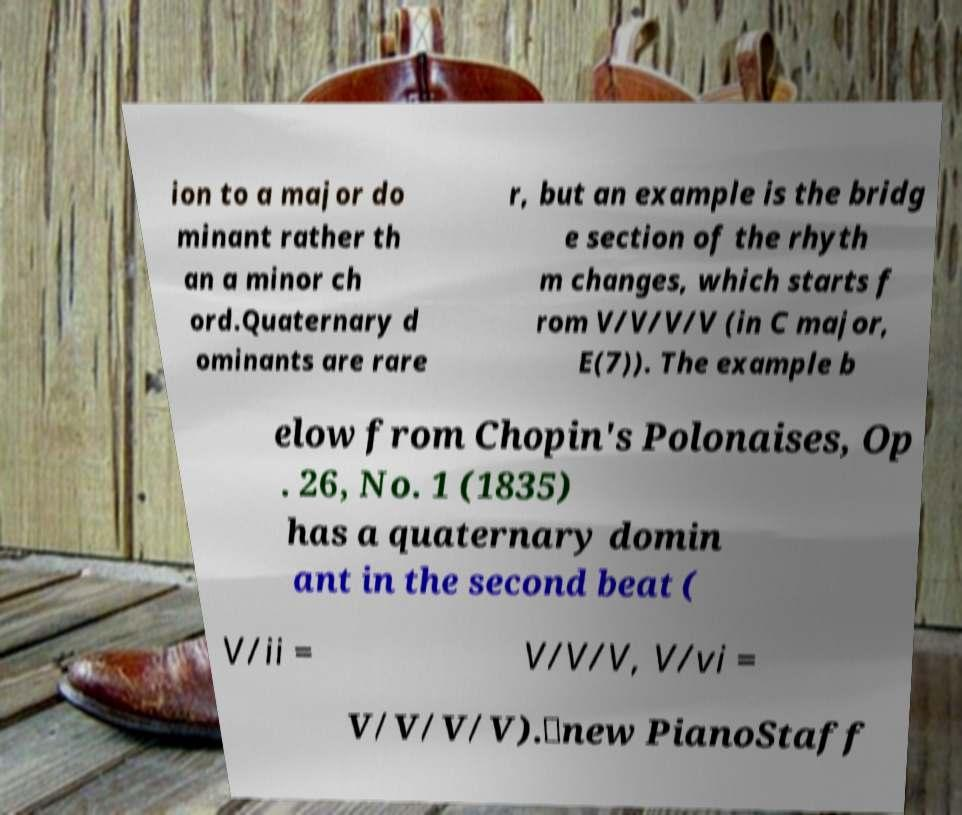Could you extract and type out the text from this image? ion to a major do minant rather th an a minor ch ord.Quaternary d ominants are rare r, but an example is the bridg e section of the rhyth m changes, which starts f rom V/V/V/V (in C major, E(7)). The example b elow from Chopin's Polonaises, Op . 26, No. 1 (1835) has a quaternary domin ant in the second beat ( V/ii = V/V/V, V/vi = V/V/V/V).\new PianoStaff 